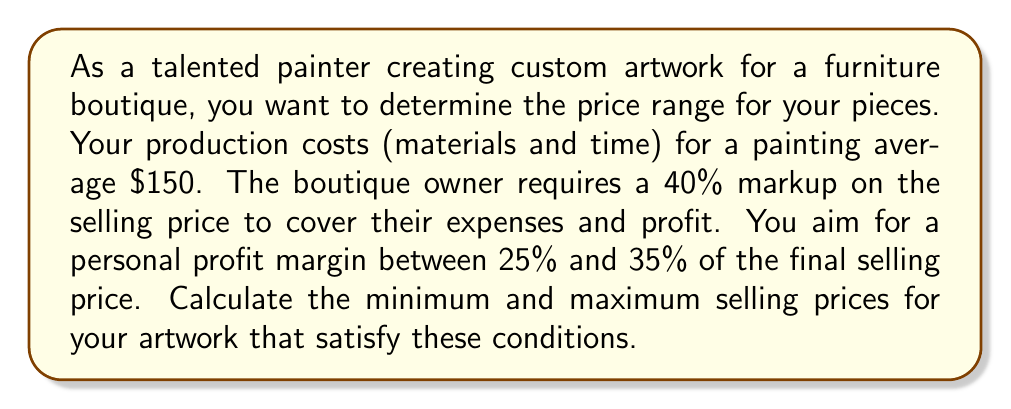Teach me how to tackle this problem. Let's approach this step-by-step:

1) Let $x$ be the selling price of the artwork.

2) The boutique owner's markup is 40% of the selling price:
   Boutique markup = $0.40x$

3) Your production cost is $150.

4) Your profit should be between 25% and 35% of the selling price:
   $0.25x \leq$ Your profit $\leq 0.35x$

5) The selling price consists of your production cost, your profit, and the boutique's markup:
   $x = 150 + $ Your profit $+ 0.40x$

6) Substituting the profit range into this equation:
   $x = 150 + 0.25x + 0.40x$ (minimum price)
   $x = 150 + 0.35x + 0.40x$ (maximum price)

7) Solving for the minimum price:
   $x = 150 + 0.65x$
   $0.35x = 150$
   $x = \frac{150}{0.35} \approx 428.57$

8) Solving for the maximum price:
   $x = 150 + 0.75x$
   $0.25x = 150$
   $x = \frac{150}{0.25} = 600$

Therefore, the price range is approximately $428.57 to $600.
Answer: The selling price range for the artwork should be between $428.57 and $600. 